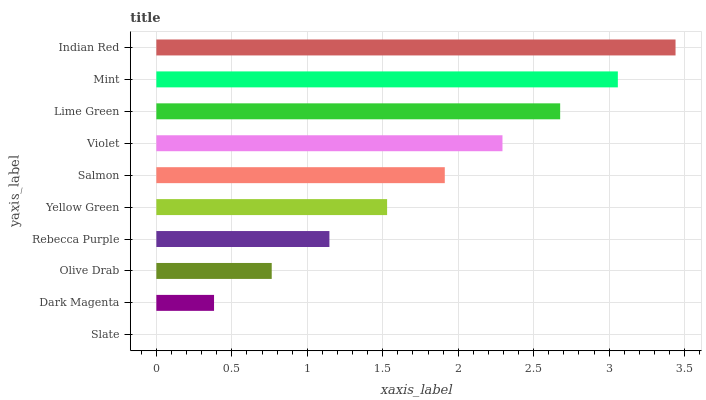Is Slate the minimum?
Answer yes or no. Yes. Is Indian Red the maximum?
Answer yes or no. Yes. Is Dark Magenta the minimum?
Answer yes or no. No. Is Dark Magenta the maximum?
Answer yes or no. No. Is Dark Magenta greater than Slate?
Answer yes or no. Yes. Is Slate less than Dark Magenta?
Answer yes or no. Yes. Is Slate greater than Dark Magenta?
Answer yes or no. No. Is Dark Magenta less than Slate?
Answer yes or no. No. Is Salmon the high median?
Answer yes or no. Yes. Is Yellow Green the low median?
Answer yes or no. Yes. Is Rebecca Purple the high median?
Answer yes or no. No. Is Rebecca Purple the low median?
Answer yes or no. No. 